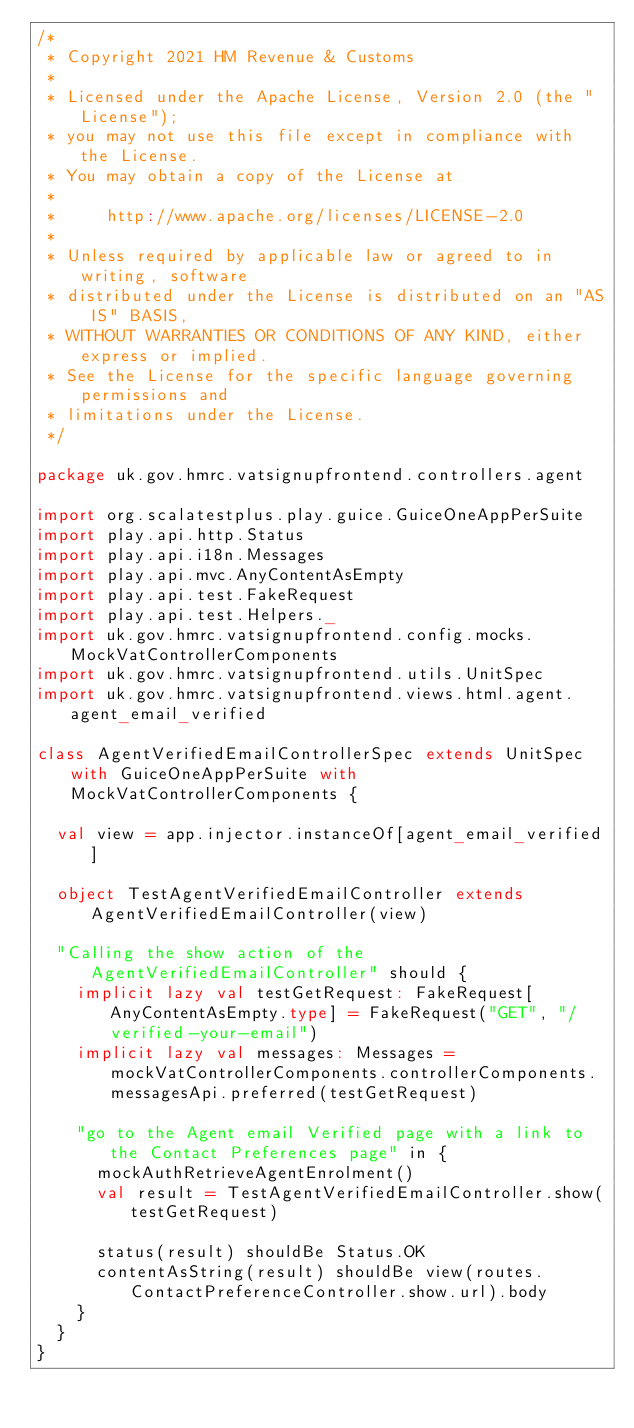<code> <loc_0><loc_0><loc_500><loc_500><_Scala_>/*
 * Copyright 2021 HM Revenue & Customs
 *
 * Licensed under the Apache License, Version 2.0 (the "License");
 * you may not use this file except in compliance with the License.
 * You may obtain a copy of the License at
 *
 *     http://www.apache.org/licenses/LICENSE-2.0
 *
 * Unless required by applicable law or agreed to in writing, software
 * distributed under the License is distributed on an "AS IS" BASIS,
 * WITHOUT WARRANTIES OR CONDITIONS OF ANY KIND, either express or implied.
 * See the License for the specific language governing permissions and
 * limitations under the License.
 */

package uk.gov.hmrc.vatsignupfrontend.controllers.agent

import org.scalatestplus.play.guice.GuiceOneAppPerSuite
import play.api.http.Status
import play.api.i18n.Messages
import play.api.mvc.AnyContentAsEmpty
import play.api.test.FakeRequest
import play.api.test.Helpers._
import uk.gov.hmrc.vatsignupfrontend.config.mocks.MockVatControllerComponents
import uk.gov.hmrc.vatsignupfrontend.utils.UnitSpec
import uk.gov.hmrc.vatsignupfrontend.views.html.agent.agent_email_verified

class AgentVerifiedEmailControllerSpec extends UnitSpec with GuiceOneAppPerSuite with MockVatControllerComponents {

  val view = app.injector.instanceOf[agent_email_verified]

  object TestAgentVerifiedEmailController extends AgentVerifiedEmailController(view)

  "Calling the show action of the AgentVerifiedEmailController" should {
    implicit lazy val testGetRequest: FakeRequest[AnyContentAsEmpty.type] = FakeRequest("GET", "/verified-your-email")
    implicit lazy val messages: Messages = mockVatControllerComponents.controllerComponents.messagesApi.preferred(testGetRequest)

    "go to the Agent email Verified page with a link to the Contact Preferences page" in {
      mockAuthRetrieveAgentEnrolment()
      val result = TestAgentVerifiedEmailController.show(testGetRequest)

      status(result) shouldBe Status.OK
      contentAsString(result) shouldBe view(routes.ContactPreferenceController.show.url).body
    }
  }
}
</code> 